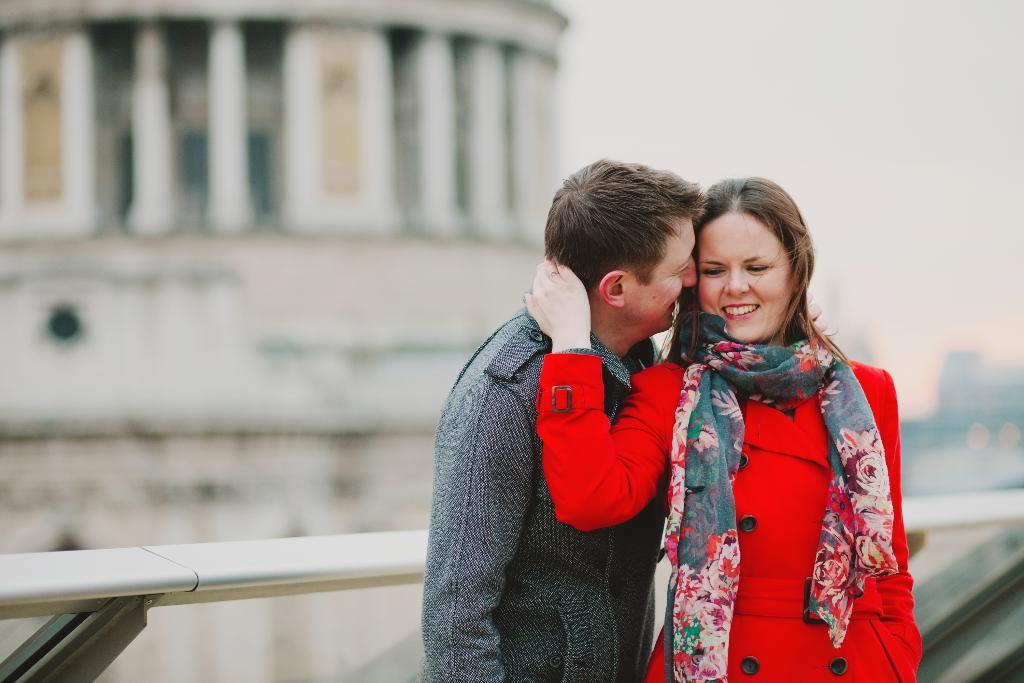Who are the two people in the foreground of the picture? There is a couple in the foreground of the picture. What are the couple doing in the image? The couple is standing near a railing. What can be seen in the background of the image? The background of the image is blurred, but there are buildings visible. How many attempts did the couple make to fix the broken cent in the image? There is no mention of a broken cent or any attempts to fix it in the image. 